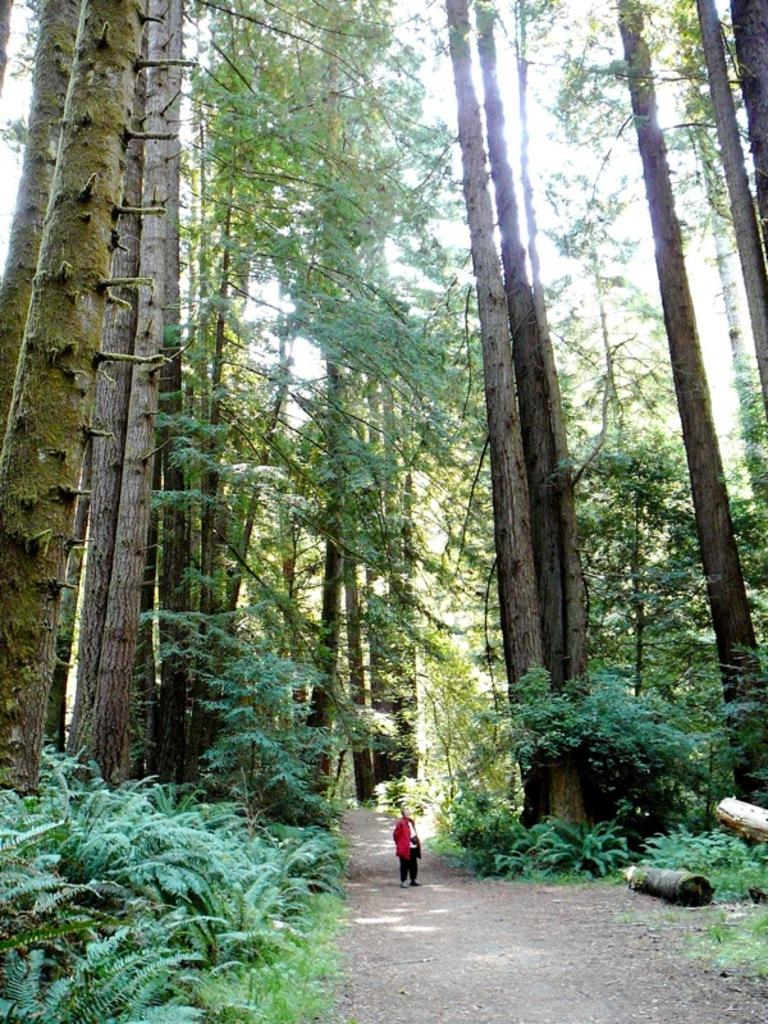What is the main subject in the image? There is a person standing in the image. What type of vegetation can be seen in the image? There are groups of trees and plants in the image. What is the ground covered with in the image? There is grass in the image. What is visible at the top of the image? The sky is visible at the top of the image. Where is the vase located in the image? There is no vase present in the image. What type of town can be seen in the image? The image does not depict a town; it features a person standing amidst vegetation and grass. 